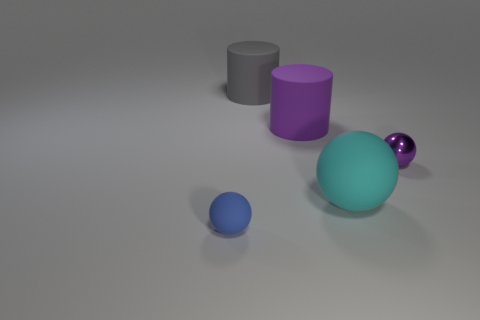Add 3 large red rubber cubes. How many objects exist? 8 Subtract all cylinders. How many objects are left? 3 Add 5 gray rubber things. How many gray rubber things exist? 6 Subtract 0 yellow cubes. How many objects are left? 5 Subtract all gray objects. Subtract all red balls. How many objects are left? 4 Add 1 metal things. How many metal things are left? 2 